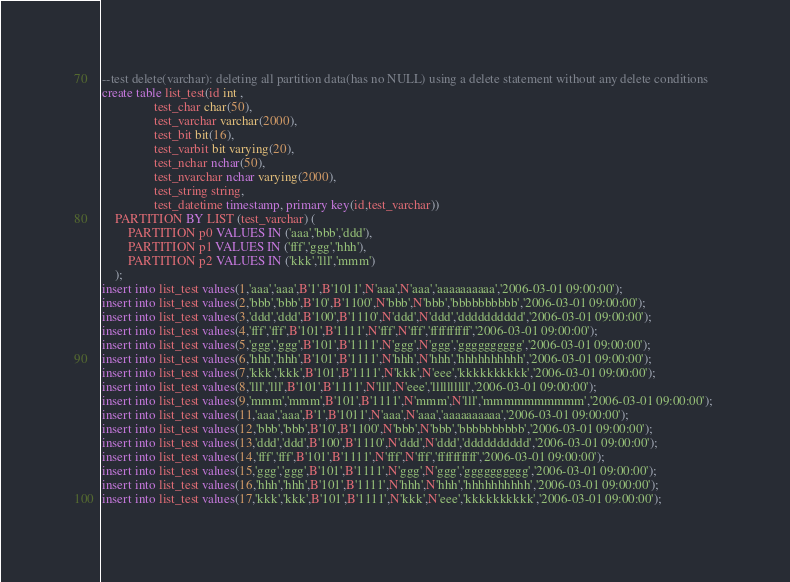Convert code to text. <code><loc_0><loc_0><loc_500><loc_500><_SQL_>--test delete(varchar): deleting all partition data(has no NULL) using a delete statement without any delete conditions
create table list_test(id int ,
				test_char char(50),
				test_varchar varchar(2000),
				test_bit bit(16),
				test_varbit bit varying(20),
				test_nchar nchar(50),
				test_nvarchar nchar varying(2000),
				test_string string,
				test_datetime timestamp, primary key(id,test_varchar))
	PARTITION BY LIST (test_varchar) (
	    PARTITION p0 VALUES IN ('aaa','bbb','ddd'),
	    PARTITION p1 VALUES IN ('fff','ggg','hhh'),
	    PARTITION p2 VALUES IN ('kkk','lll','mmm')
	);
insert into list_test values(1,'aaa','aaa',B'1',B'1011',N'aaa',N'aaa','aaaaaaaaaa','2006-03-01 09:00:00');   
insert into list_test values(2,'bbb','bbb',B'10',B'1100',N'bbb',N'bbb','bbbbbbbbbb','2006-03-01 09:00:00');  
insert into list_test values(3,'ddd','ddd',B'100',B'1110',N'ddd',N'ddd','dddddddddd','2006-03-01 09:00:00'); 
insert into list_test values(4,'fff','fff',B'101',B'1111',N'fff',N'fff','ffffffffff','2006-03-01 09:00:00'); 
insert into list_test values(5,'ggg','ggg',B'101',B'1111',N'ggg',N'ggg','gggggggggg','2006-03-01 09:00:00'); 
insert into list_test values(6,'hhh','hhh',B'101',B'1111',N'hhh',N'hhh','hhhhhhhhhh','2006-03-01 09:00:00'); 
insert into list_test values(7,'kkk','kkk',B'101',B'1111',N'kkk',N'eee','kkkkkkkkkk','2006-03-01 09:00:00'); 
insert into list_test values(8,'lll','lll',B'101',B'1111',N'lll',N'eee','llllllllll','2006-03-01 09:00:00'); 
insert into list_test values(9,'mmm','mmm',B'101',B'1111',N'mmm',N'lll','mmmmmmmmmm','2006-03-01 09:00:00'); 
insert into list_test values(11,'aaa','aaa',B'1',B'1011',N'aaa',N'aaa','aaaaaaaaaa','2006-03-01 09:00:00');  
insert into list_test values(12,'bbb','bbb',B'10',B'1100',N'bbb',N'bbb','bbbbbbbbbb','2006-03-01 09:00:00'); 
insert into list_test values(13,'ddd','ddd',B'100',B'1110',N'ddd',N'ddd','dddddddddd','2006-03-01 09:00:00');
insert into list_test values(14,'fff','fff',B'101',B'1111',N'fff',N'fff','ffffffffff','2006-03-01 09:00:00');
insert into list_test values(15,'ggg','ggg',B'101',B'1111',N'ggg',N'ggg','gggggggggg','2006-03-01 09:00:00');
insert into list_test values(16,'hhh','hhh',B'101',B'1111',N'hhh',N'hhh','hhhhhhhhhh','2006-03-01 09:00:00');
insert into list_test values(17,'kkk','kkk',B'101',B'1111',N'kkk',N'eee','kkkkkkkkkk','2006-03-01 09:00:00');</code> 